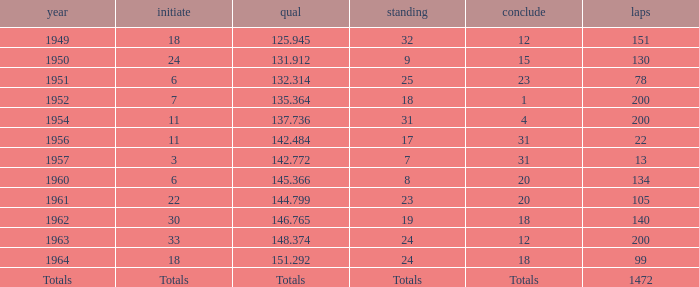Name the year for laps of 200 and rank of 24 1963.0. 